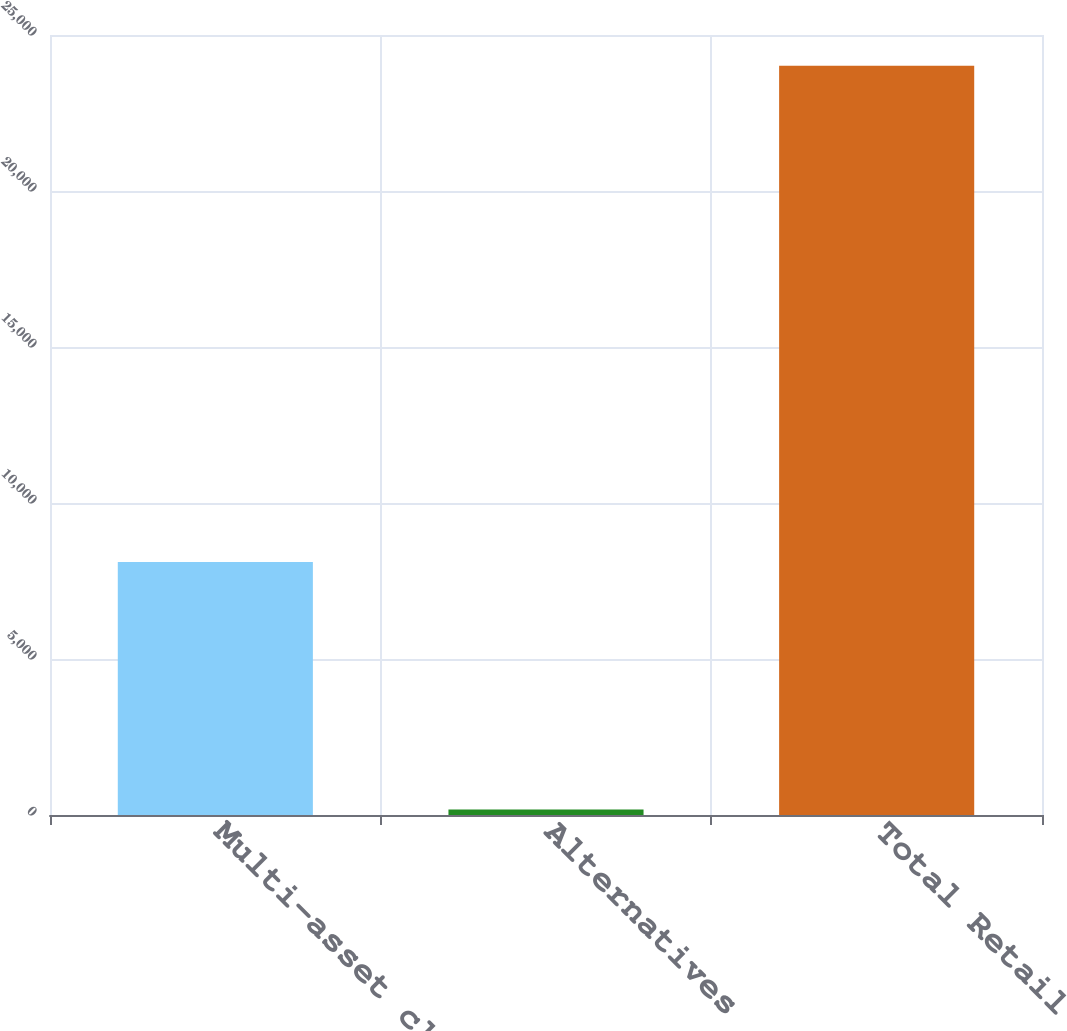Convert chart. <chart><loc_0><loc_0><loc_500><loc_500><bar_chart><fcel>Multi-asset class<fcel>Alternatives<fcel>Total Retail<nl><fcel>8108<fcel>177<fcel>24016<nl></chart> 